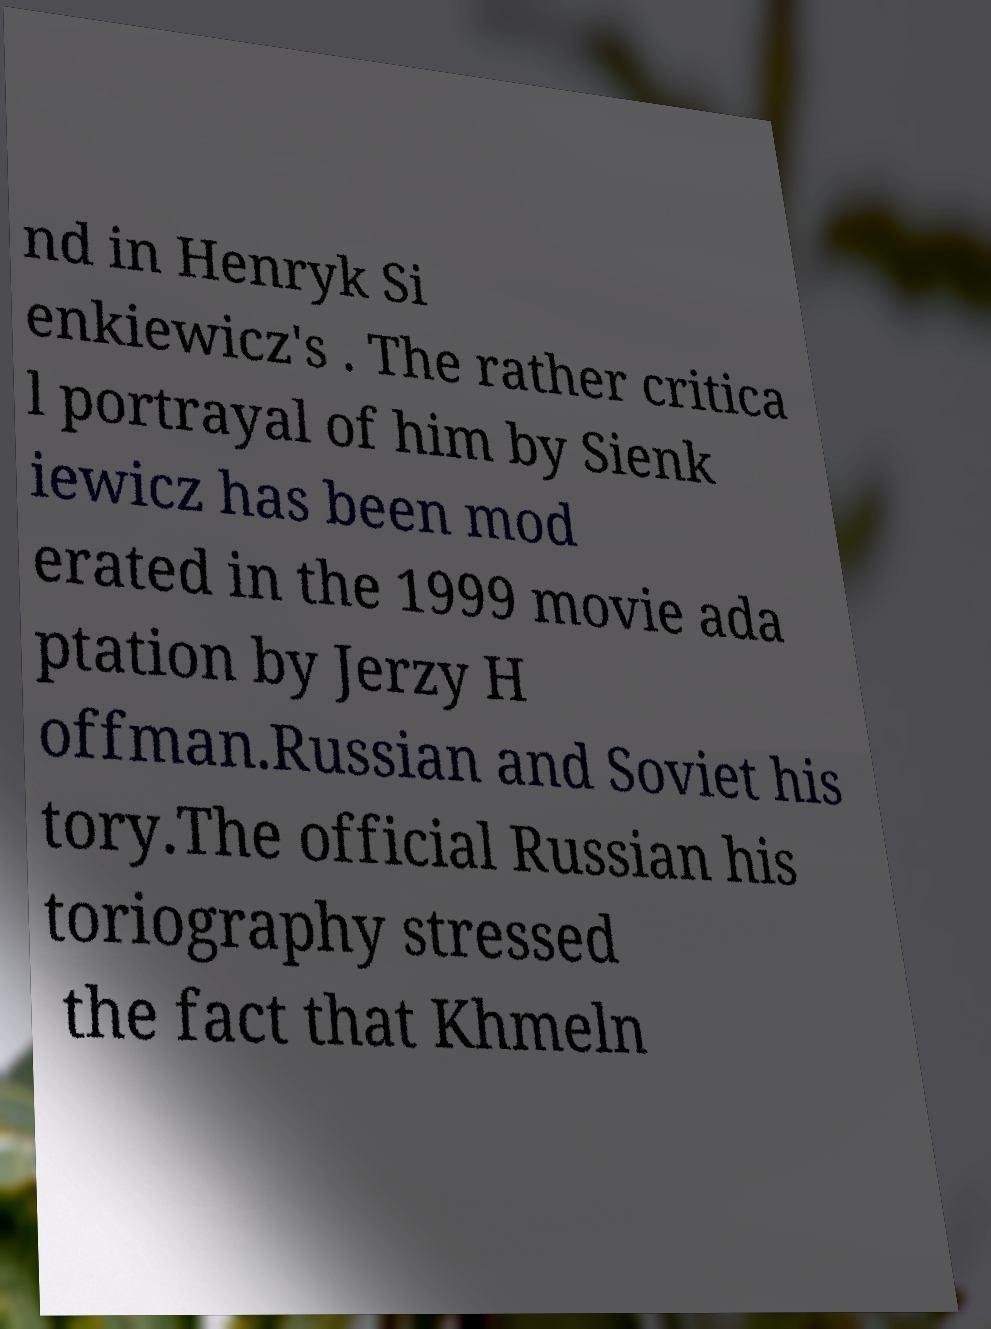For documentation purposes, I need the text within this image transcribed. Could you provide that? nd in Henryk Si enkiewicz's . The rather critica l portrayal of him by Sienk iewicz has been mod erated in the 1999 movie ada ptation by Jerzy H offman.Russian and Soviet his tory.The official Russian his toriography stressed the fact that Khmeln 